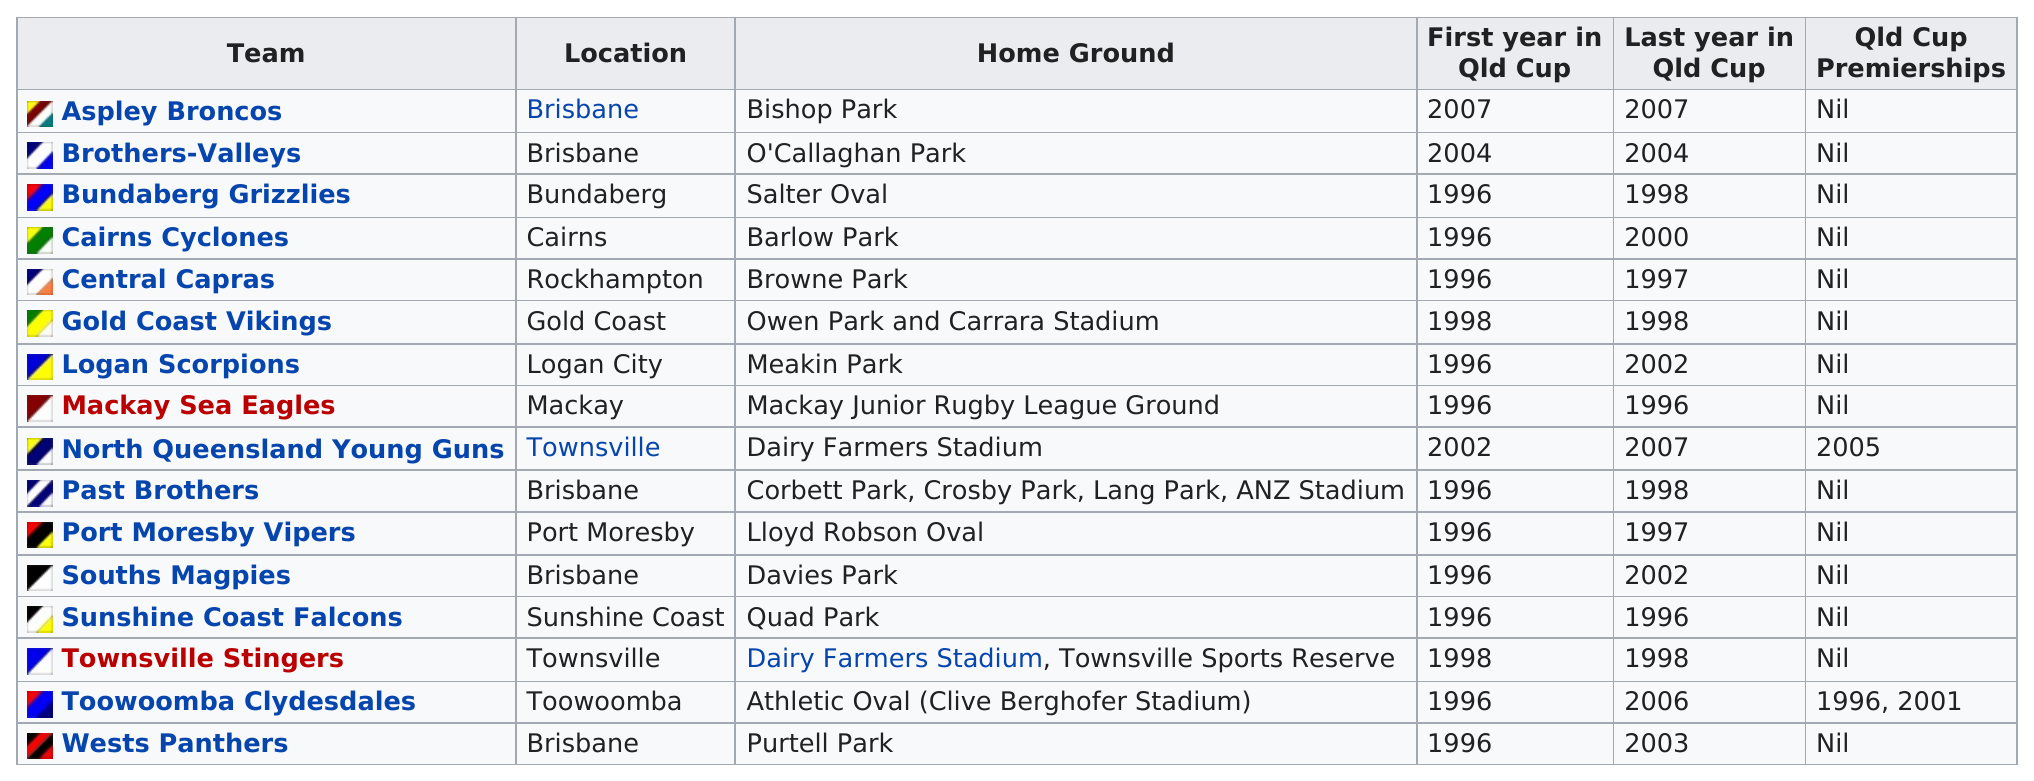Specify some key components in this picture. The Bundaberg Grizzlis had QLD Cup in 1996. As of 2003, the West Panthers have not participated in the QLD Cup. Toowoomba Clydesdales had more QLD Cup than North Queensland Young Guns. The total number of teams located in Townsville is two. A total of 14 teams have not won any Queensland Cup premierships. 